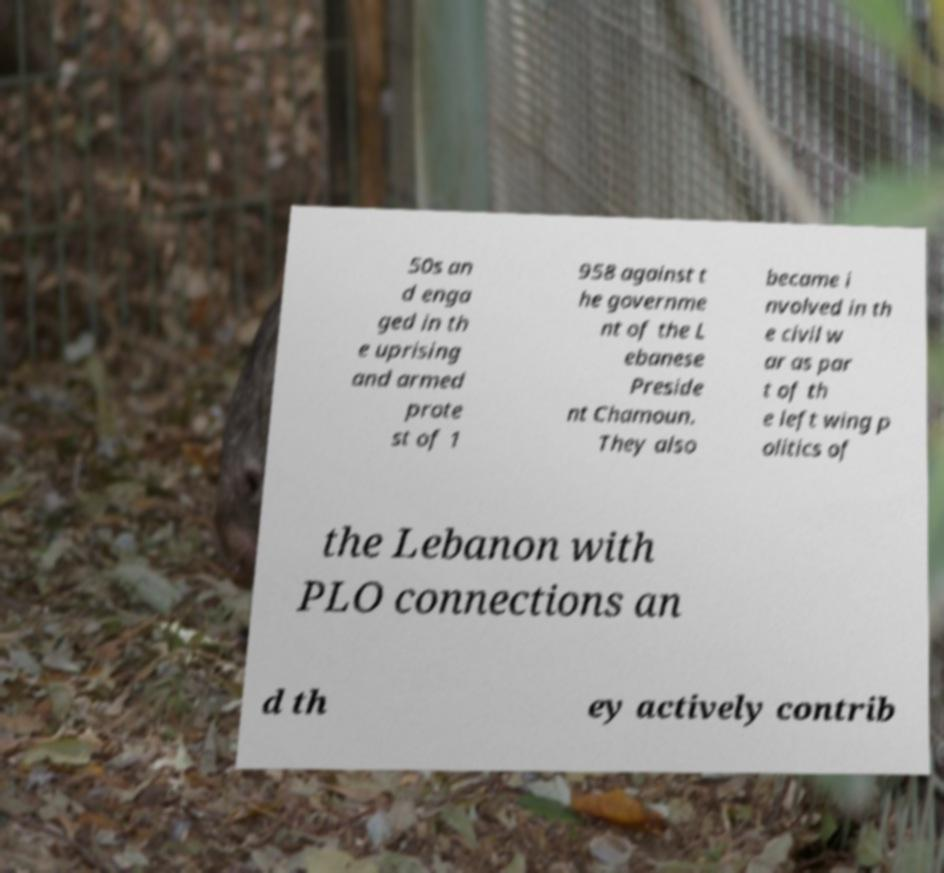Could you assist in decoding the text presented in this image and type it out clearly? 50s an d enga ged in th e uprising and armed prote st of 1 958 against t he governme nt of the L ebanese Preside nt Chamoun. They also became i nvolved in th e civil w ar as par t of th e left wing p olitics of the Lebanon with PLO connections an d th ey actively contrib 